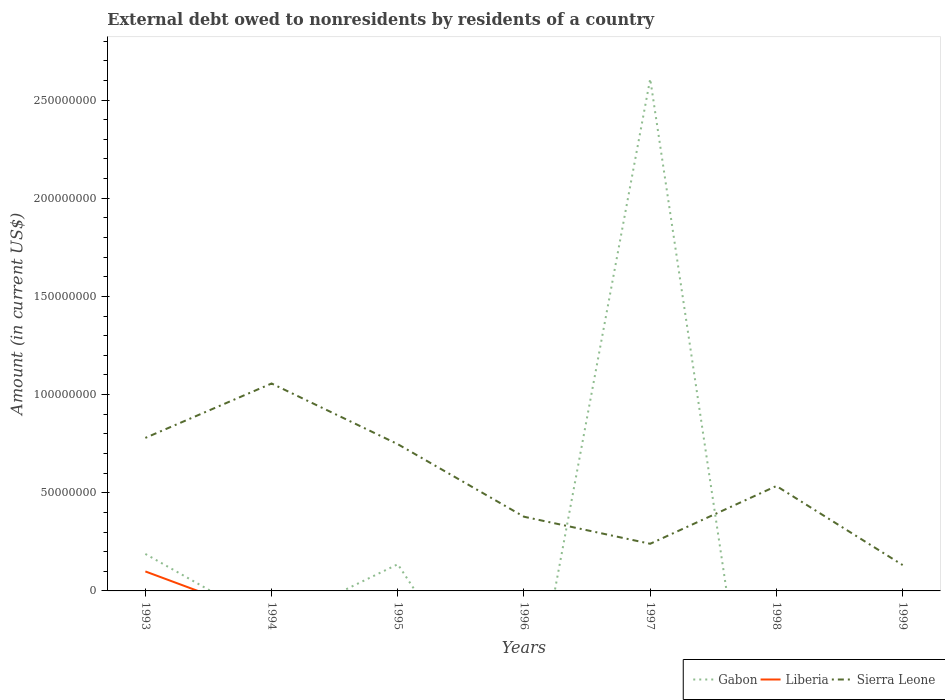How many different coloured lines are there?
Provide a short and direct response. 3. Does the line corresponding to Gabon intersect with the line corresponding to Liberia?
Your answer should be very brief. Yes. Is the number of lines equal to the number of legend labels?
Make the answer very short. No. Across all years, what is the maximum external debt owed by residents in Gabon?
Offer a terse response. 0. What is the total external debt owed by residents in Sierra Leone in the graph?
Give a very brief answer. 5.22e+07. What is the difference between the highest and the second highest external debt owed by residents in Liberia?
Make the answer very short. 9.92e+06. Is the external debt owed by residents in Sierra Leone strictly greater than the external debt owed by residents in Liberia over the years?
Your response must be concise. No. How many lines are there?
Your answer should be very brief. 3. How many years are there in the graph?
Make the answer very short. 7. Does the graph contain any zero values?
Ensure brevity in your answer.  Yes. How many legend labels are there?
Ensure brevity in your answer.  3. How are the legend labels stacked?
Give a very brief answer. Horizontal. What is the title of the graph?
Keep it short and to the point. External debt owed to nonresidents by residents of a country. Does "Greenland" appear as one of the legend labels in the graph?
Make the answer very short. No. What is the label or title of the X-axis?
Ensure brevity in your answer.  Years. What is the label or title of the Y-axis?
Give a very brief answer. Amount (in current US$). What is the Amount (in current US$) in Gabon in 1993?
Offer a very short reply. 1.88e+07. What is the Amount (in current US$) in Liberia in 1993?
Your answer should be very brief. 9.92e+06. What is the Amount (in current US$) of Sierra Leone in 1993?
Keep it short and to the point. 7.79e+07. What is the Amount (in current US$) of Sierra Leone in 1994?
Keep it short and to the point. 1.06e+08. What is the Amount (in current US$) of Gabon in 1995?
Make the answer very short. 1.36e+07. What is the Amount (in current US$) in Sierra Leone in 1995?
Your answer should be very brief. 7.47e+07. What is the Amount (in current US$) in Gabon in 1996?
Offer a very short reply. 0. What is the Amount (in current US$) in Liberia in 1996?
Ensure brevity in your answer.  0. What is the Amount (in current US$) in Sierra Leone in 1996?
Provide a short and direct response. 3.78e+07. What is the Amount (in current US$) of Gabon in 1997?
Your response must be concise. 2.61e+08. What is the Amount (in current US$) of Liberia in 1997?
Provide a short and direct response. 0. What is the Amount (in current US$) of Sierra Leone in 1997?
Your response must be concise. 2.40e+07. What is the Amount (in current US$) in Sierra Leone in 1998?
Make the answer very short. 5.34e+07. What is the Amount (in current US$) of Sierra Leone in 1999?
Offer a very short reply. 1.32e+07. Across all years, what is the maximum Amount (in current US$) in Gabon?
Offer a terse response. 2.61e+08. Across all years, what is the maximum Amount (in current US$) of Liberia?
Ensure brevity in your answer.  9.92e+06. Across all years, what is the maximum Amount (in current US$) of Sierra Leone?
Keep it short and to the point. 1.06e+08. Across all years, what is the minimum Amount (in current US$) of Sierra Leone?
Your answer should be very brief. 1.32e+07. What is the total Amount (in current US$) in Gabon in the graph?
Keep it short and to the point. 2.93e+08. What is the total Amount (in current US$) in Liberia in the graph?
Give a very brief answer. 9.92e+06. What is the total Amount (in current US$) in Sierra Leone in the graph?
Provide a short and direct response. 3.87e+08. What is the difference between the Amount (in current US$) of Sierra Leone in 1993 and that in 1994?
Your answer should be very brief. -2.77e+07. What is the difference between the Amount (in current US$) of Gabon in 1993 and that in 1995?
Make the answer very short. 5.26e+06. What is the difference between the Amount (in current US$) of Sierra Leone in 1993 and that in 1995?
Ensure brevity in your answer.  3.20e+06. What is the difference between the Amount (in current US$) in Sierra Leone in 1993 and that in 1996?
Give a very brief answer. 4.02e+07. What is the difference between the Amount (in current US$) of Gabon in 1993 and that in 1997?
Ensure brevity in your answer.  -2.42e+08. What is the difference between the Amount (in current US$) of Sierra Leone in 1993 and that in 1997?
Give a very brief answer. 5.39e+07. What is the difference between the Amount (in current US$) of Sierra Leone in 1993 and that in 1998?
Your answer should be compact. 2.45e+07. What is the difference between the Amount (in current US$) of Sierra Leone in 1993 and that in 1999?
Your answer should be compact. 6.48e+07. What is the difference between the Amount (in current US$) of Sierra Leone in 1994 and that in 1995?
Your response must be concise. 3.09e+07. What is the difference between the Amount (in current US$) of Sierra Leone in 1994 and that in 1996?
Your answer should be compact. 6.79e+07. What is the difference between the Amount (in current US$) of Sierra Leone in 1994 and that in 1997?
Give a very brief answer. 8.16e+07. What is the difference between the Amount (in current US$) in Sierra Leone in 1994 and that in 1998?
Your response must be concise. 5.22e+07. What is the difference between the Amount (in current US$) of Sierra Leone in 1994 and that in 1999?
Keep it short and to the point. 9.25e+07. What is the difference between the Amount (in current US$) of Sierra Leone in 1995 and that in 1996?
Provide a succinct answer. 3.69e+07. What is the difference between the Amount (in current US$) of Gabon in 1995 and that in 1997?
Provide a succinct answer. -2.47e+08. What is the difference between the Amount (in current US$) in Sierra Leone in 1995 and that in 1997?
Provide a succinct answer. 5.07e+07. What is the difference between the Amount (in current US$) of Sierra Leone in 1995 and that in 1998?
Ensure brevity in your answer.  2.13e+07. What is the difference between the Amount (in current US$) in Sierra Leone in 1995 and that in 1999?
Provide a short and direct response. 6.16e+07. What is the difference between the Amount (in current US$) in Sierra Leone in 1996 and that in 1997?
Offer a terse response. 1.38e+07. What is the difference between the Amount (in current US$) in Sierra Leone in 1996 and that in 1998?
Offer a terse response. -1.57e+07. What is the difference between the Amount (in current US$) in Sierra Leone in 1996 and that in 1999?
Make the answer very short. 2.46e+07. What is the difference between the Amount (in current US$) of Sierra Leone in 1997 and that in 1998?
Keep it short and to the point. -2.94e+07. What is the difference between the Amount (in current US$) in Sierra Leone in 1997 and that in 1999?
Your answer should be very brief. 1.08e+07. What is the difference between the Amount (in current US$) in Sierra Leone in 1998 and that in 1999?
Provide a succinct answer. 4.03e+07. What is the difference between the Amount (in current US$) in Gabon in 1993 and the Amount (in current US$) in Sierra Leone in 1994?
Keep it short and to the point. -8.68e+07. What is the difference between the Amount (in current US$) in Liberia in 1993 and the Amount (in current US$) in Sierra Leone in 1994?
Your response must be concise. -9.57e+07. What is the difference between the Amount (in current US$) of Gabon in 1993 and the Amount (in current US$) of Sierra Leone in 1995?
Make the answer very short. -5.59e+07. What is the difference between the Amount (in current US$) in Liberia in 1993 and the Amount (in current US$) in Sierra Leone in 1995?
Make the answer very short. -6.48e+07. What is the difference between the Amount (in current US$) in Gabon in 1993 and the Amount (in current US$) in Sierra Leone in 1996?
Provide a short and direct response. -1.89e+07. What is the difference between the Amount (in current US$) of Liberia in 1993 and the Amount (in current US$) of Sierra Leone in 1996?
Your answer should be very brief. -2.79e+07. What is the difference between the Amount (in current US$) of Gabon in 1993 and the Amount (in current US$) of Sierra Leone in 1997?
Provide a short and direct response. -5.18e+06. What is the difference between the Amount (in current US$) of Liberia in 1993 and the Amount (in current US$) of Sierra Leone in 1997?
Give a very brief answer. -1.41e+07. What is the difference between the Amount (in current US$) of Gabon in 1993 and the Amount (in current US$) of Sierra Leone in 1998?
Your answer should be very brief. -3.46e+07. What is the difference between the Amount (in current US$) of Liberia in 1993 and the Amount (in current US$) of Sierra Leone in 1998?
Give a very brief answer. -4.35e+07. What is the difference between the Amount (in current US$) of Gabon in 1993 and the Amount (in current US$) of Sierra Leone in 1999?
Give a very brief answer. 5.66e+06. What is the difference between the Amount (in current US$) of Liberia in 1993 and the Amount (in current US$) of Sierra Leone in 1999?
Ensure brevity in your answer.  -3.25e+06. What is the difference between the Amount (in current US$) of Gabon in 1995 and the Amount (in current US$) of Sierra Leone in 1996?
Provide a succinct answer. -2.42e+07. What is the difference between the Amount (in current US$) of Gabon in 1995 and the Amount (in current US$) of Sierra Leone in 1997?
Your answer should be compact. -1.04e+07. What is the difference between the Amount (in current US$) of Gabon in 1995 and the Amount (in current US$) of Sierra Leone in 1998?
Give a very brief answer. -3.99e+07. What is the difference between the Amount (in current US$) of Gabon in 1995 and the Amount (in current US$) of Sierra Leone in 1999?
Provide a succinct answer. 4.07e+05. What is the difference between the Amount (in current US$) of Gabon in 1997 and the Amount (in current US$) of Sierra Leone in 1998?
Ensure brevity in your answer.  2.07e+08. What is the difference between the Amount (in current US$) of Gabon in 1997 and the Amount (in current US$) of Sierra Leone in 1999?
Provide a succinct answer. 2.48e+08. What is the average Amount (in current US$) of Gabon per year?
Your answer should be very brief. 4.19e+07. What is the average Amount (in current US$) of Liberia per year?
Offer a very short reply. 1.42e+06. What is the average Amount (in current US$) of Sierra Leone per year?
Provide a short and direct response. 5.53e+07. In the year 1993, what is the difference between the Amount (in current US$) of Gabon and Amount (in current US$) of Liberia?
Your response must be concise. 8.92e+06. In the year 1993, what is the difference between the Amount (in current US$) in Gabon and Amount (in current US$) in Sierra Leone?
Your answer should be compact. -5.91e+07. In the year 1993, what is the difference between the Amount (in current US$) in Liberia and Amount (in current US$) in Sierra Leone?
Offer a terse response. -6.80e+07. In the year 1995, what is the difference between the Amount (in current US$) in Gabon and Amount (in current US$) in Sierra Leone?
Provide a succinct answer. -6.12e+07. In the year 1997, what is the difference between the Amount (in current US$) of Gabon and Amount (in current US$) of Sierra Leone?
Ensure brevity in your answer.  2.37e+08. What is the ratio of the Amount (in current US$) of Sierra Leone in 1993 to that in 1994?
Provide a succinct answer. 0.74. What is the ratio of the Amount (in current US$) of Gabon in 1993 to that in 1995?
Offer a very short reply. 1.39. What is the ratio of the Amount (in current US$) in Sierra Leone in 1993 to that in 1995?
Offer a terse response. 1.04. What is the ratio of the Amount (in current US$) in Sierra Leone in 1993 to that in 1996?
Your answer should be very brief. 2.06. What is the ratio of the Amount (in current US$) of Gabon in 1993 to that in 1997?
Provide a succinct answer. 0.07. What is the ratio of the Amount (in current US$) in Sierra Leone in 1993 to that in 1997?
Offer a very short reply. 3.25. What is the ratio of the Amount (in current US$) in Sierra Leone in 1993 to that in 1998?
Your answer should be compact. 1.46. What is the ratio of the Amount (in current US$) in Sierra Leone in 1993 to that in 1999?
Your answer should be very brief. 5.91. What is the ratio of the Amount (in current US$) of Sierra Leone in 1994 to that in 1995?
Give a very brief answer. 1.41. What is the ratio of the Amount (in current US$) in Sierra Leone in 1994 to that in 1996?
Offer a terse response. 2.8. What is the ratio of the Amount (in current US$) of Sierra Leone in 1994 to that in 1997?
Provide a succinct answer. 4.4. What is the ratio of the Amount (in current US$) of Sierra Leone in 1994 to that in 1998?
Offer a terse response. 1.98. What is the ratio of the Amount (in current US$) of Sierra Leone in 1994 to that in 1999?
Make the answer very short. 8.02. What is the ratio of the Amount (in current US$) in Sierra Leone in 1995 to that in 1996?
Keep it short and to the point. 1.98. What is the ratio of the Amount (in current US$) of Gabon in 1995 to that in 1997?
Offer a very short reply. 0.05. What is the ratio of the Amount (in current US$) of Sierra Leone in 1995 to that in 1997?
Keep it short and to the point. 3.11. What is the ratio of the Amount (in current US$) in Sierra Leone in 1995 to that in 1998?
Give a very brief answer. 1.4. What is the ratio of the Amount (in current US$) of Sierra Leone in 1995 to that in 1999?
Ensure brevity in your answer.  5.67. What is the ratio of the Amount (in current US$) of Sierra Leone in 1996 to that in 1997?
Your response must be concise. 1.57. What is the ratio of the Amount (in current US$) in Sierra Leone in 1996 to that in 1998?
Give a very brief answer. 0.71. What is the ratio of the Amount (in current US$) of Sierra Leone in 1996 to that in 1999?
Your answer should be compact. 2.87. What is the ratio of the Amount (in current US$) in Sierra Leone in 1997 to that in 1998?
Provide a short and direct response. 0.45. What is the ratio of the Amount (in current US$) in Sierra Leone in 1997 to that in 1999?
Make the answer very short. 1.82. What is the ratio of the Amount (in current US$) in Sierra Leone in 1998 to that in 1999?
Provide a succinct answer. 4.06. What is the difference between the highest and the second highest Amount (in current US$) of Gabon?
Your response must be concise. 2.42e+08. What is the difference between the highest and the second highest Amount (in current US$) in Sierra Leone?
Ensure brevity in your answer.  2.77e+07. What is the difference between the highest and the lowest Amount (in current US$) of Gabon?
Provide a short and direct response. 2.61e+08. What is the difference between the highest and the lowest Amount (in current US$) of Liberia?
Keep it short and to the point. 9.92e+06. What is the difference between the highest and the lowest Amount (in current US$) in Sierra Leone?
Offer a very short reply. 9.25e+07. 